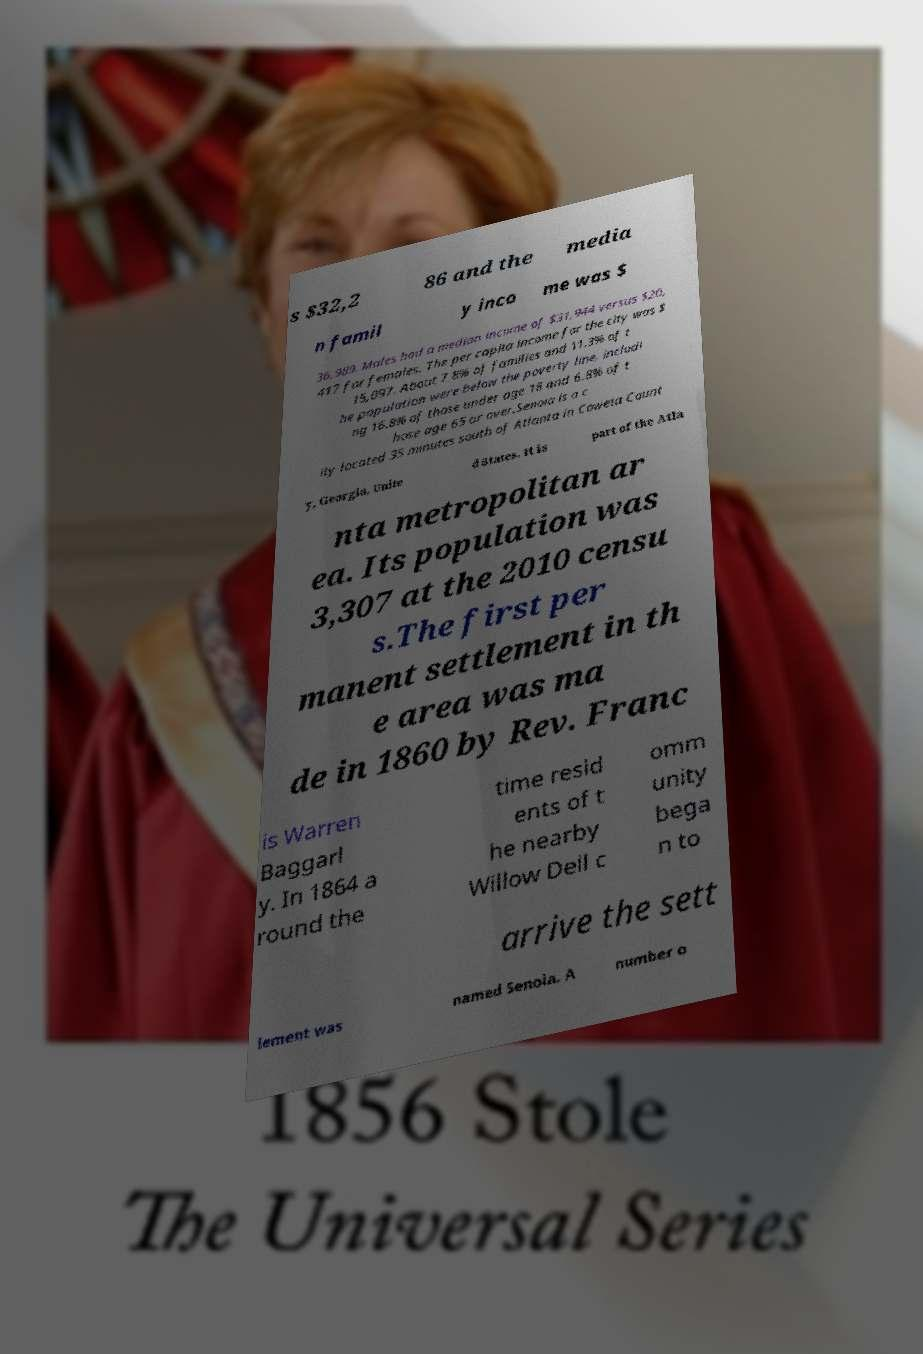Can you accurately transcribe the text from the provided image for me? s $32,2 86 and the media n famil y inco me was $ 36,989. Males had a median income of $31,944 versus $20, 417 for females. The per capita income for the city was $ 15,097. About 7.8% of families and 11.3% of t he population were below the poverty line, includi ng 16.8% of those under age 18 and 6.8% of t hose age 65 or over.Senoia is a c ity located 35 minutes south of Atlanta in Coweta Count y, Georgia, Unite d States. It is part of the Atla nta metropolitan ar ea. Its population was 3,307 at the 2010 censu s.The first per manent settlement in th e area was ma de in 1860 by Rev. Franc is Warren Baggarl y. In 1864 a round the time resid ents of t he nearby Willow Dell c omm unity bega n to arrive the sett lement was named Senoia. A number o 